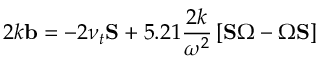<formula> <loc_0><loc_0><loc_500><loc_500>2 k b = - 2 \nu _ { t } S + 5 . 2 1 \frac { 2 k } { \omega ^ { 2 } } \left [ S \Omega - \Omega S \right ]</formula> 